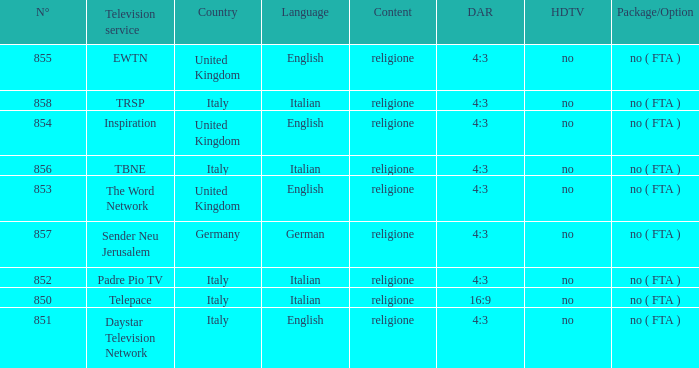How many dar are in germany? 4:3. 